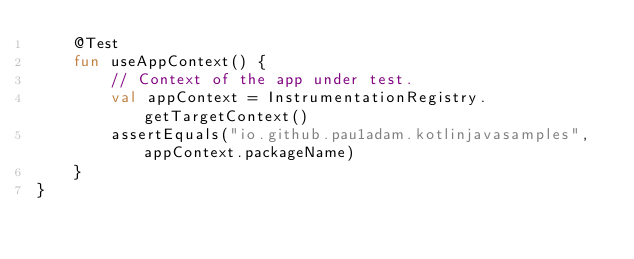<code> <loc_0><loc_0><loc_500><loc_500><_Kotlin_>    @Test
    fun useAppContext() {
        // Context of the app under test.
        val appContext = InstrumentationRegistry.getTargetContext()
        assertEquals("io.github.pau1adam.kotlinjavasamples", appContext.packageName)
    }
}
</code> 